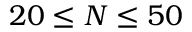<formula> <loc_0><loc_0><loc_500><loc_500>2 0 \leq N \leq 5 0</formula> 